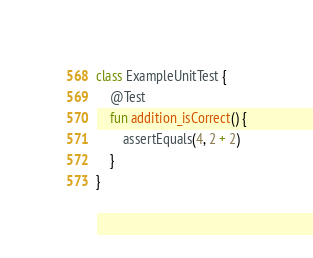Convert code to text. <code><loc_0><loc_0><loc_500><loc_500><_Kotlin_>class ExampleUnitTest {
    @Test
    fun addition_isCorrect() {
        assertEquals(4, 2 + 2)
    }
}</code> 